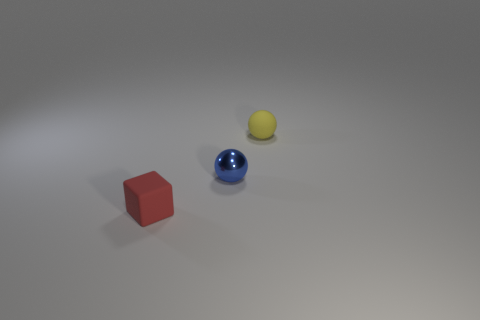Add 2 big purple metal cylinders. How many objects exist? 5 Subtract all balls. How many objects are left? 1 Subtract all yellow things. Subtract all small red objects. How many objects are left? 1 Add 3 small shiny things. How many small shiny things are left? 4 Add 2 small metal balls. How many small metal balls exist? 3 Subtract 0 green spheres. How many objects are left? 3 